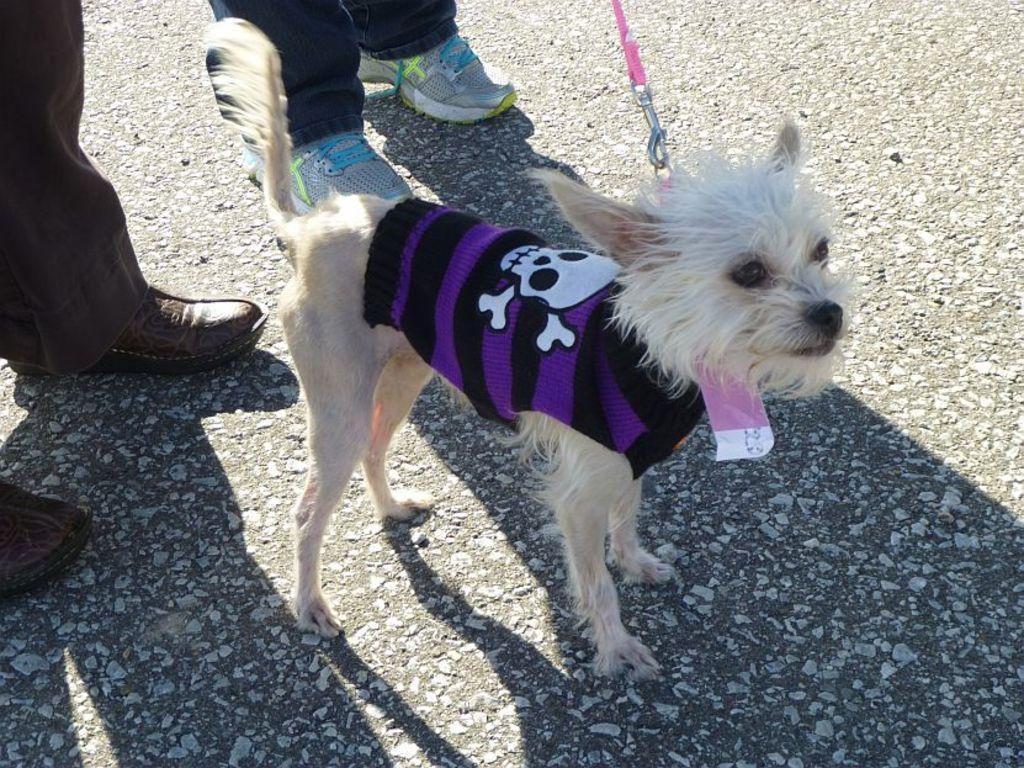Could you give a brief overview of what you see in this image? Here we can see a dog and people legs with shoes. 